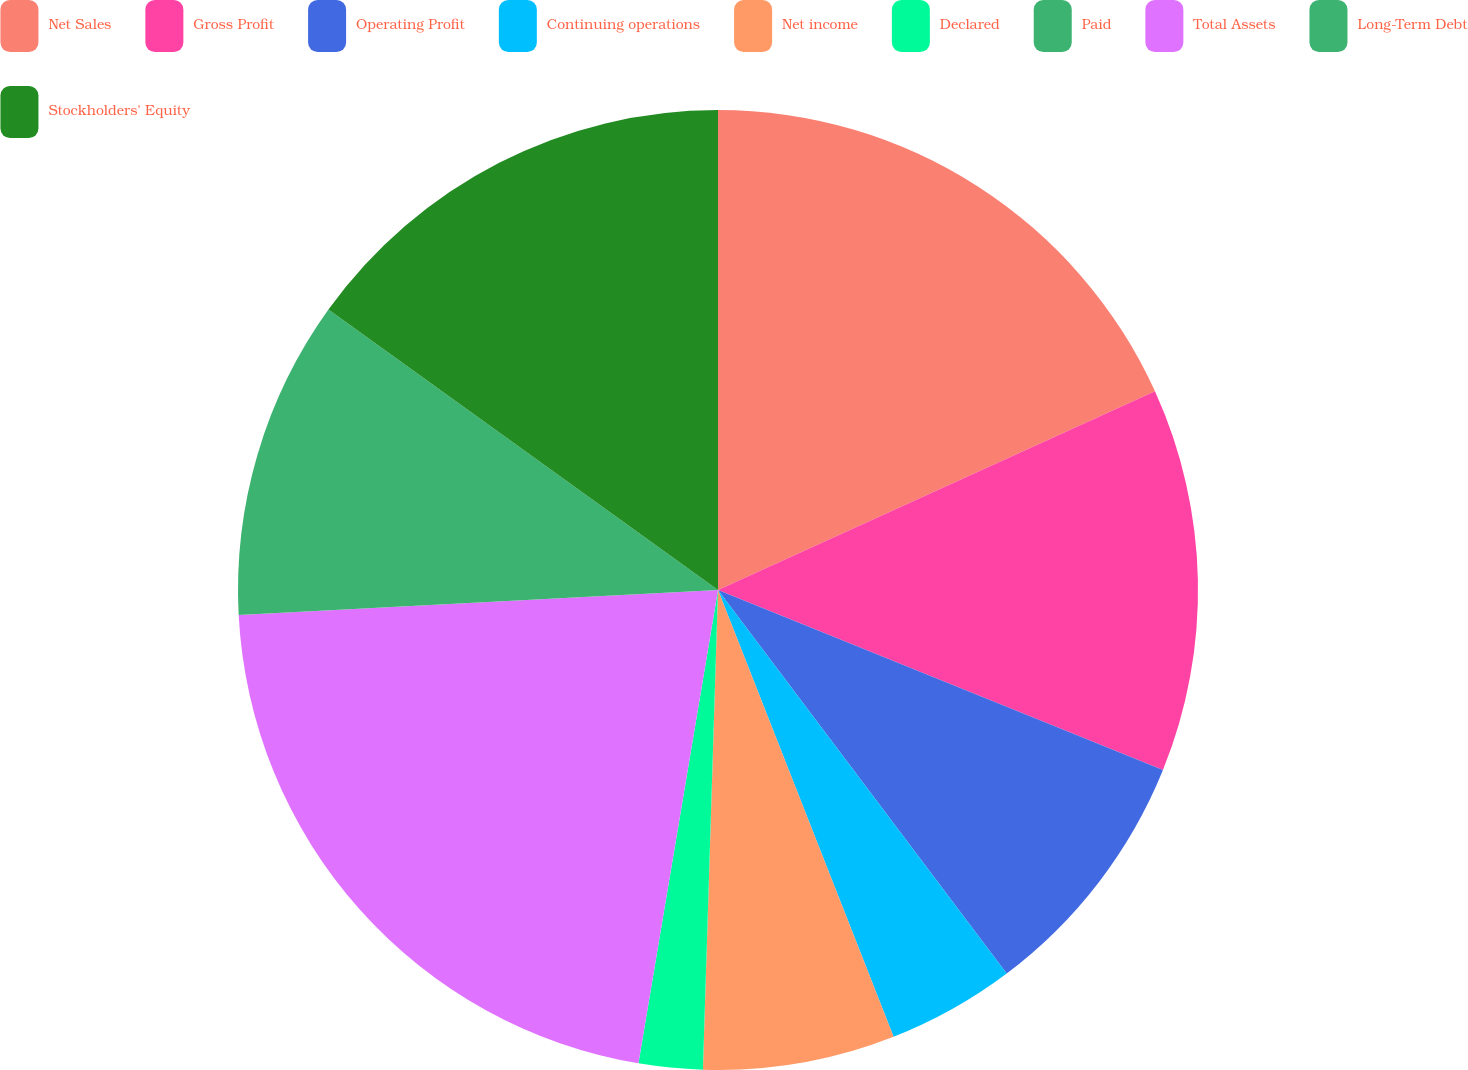<chart> <loc_0><loc_0><loc_500><loc_500><pie_chart><fcel>Net Sales<fcel>Gross Profit<fcel>Operating Profit<fcel>Continuing operations<fcel>Net income<fcel>Declared<fcel>Paid<fcel>Total Assets<fcel>Long-Term Debt<fcel>Stockholders' Equity<nl><fcel>18.21%<fcel>12.91%<fcel>8.61%<fcel>4.31%<fcel>6.46%<fcel>2.15%<fcel>0.0%<fcel>21.52%<fcel>10.76%<fcel>15.07%<nl></chart> 